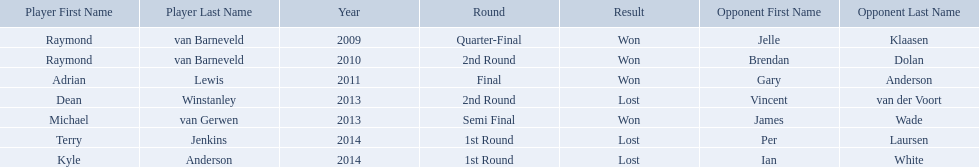Who are the players listed? Raymond van Barneveld, Raymond van Barneveld, Adrian Lewis, Dean Winstanley, Michael van Gerwen, Terry Jenkins, Kyle Anderson. Which of these players played in 2011? Adrian Lewis. Who are all the players? Raymond van Barneveld, Raymond van Barneveld, Adrian Lewis, Dean Winstanley, Michael van Gerwen, Terry Jenkins, Kyle Anderson. When did they play? 2009, 2010, 2011, 2013, 2013, 2014, 2014. And which player played in 2011? Adrian Lewis. Did terry jenkins win in 2014? Terry Jenkins, Lost. If terry jenkins lost who won? Per Laursen. Who were the players in 2014? Terry Jenkins, Kyle Anderson. Did they win or lose? Per Laursen. What players competed in the pdc world darts championship? Raymond van Barneveld, Raymond van Barneveld, Adrian Lewis, Dean Winstanley, Michael van Gerwen, Terry Jenkins, Kyle Anderson. Of these players, who lost? Dean Winstanley, Terry Jenkins, Kyle Anderson. Which of these players lost in 2014? Terry Jenkins, Kyle Anderson. What are the players other than kyle anderson? Terry Jenkins. 